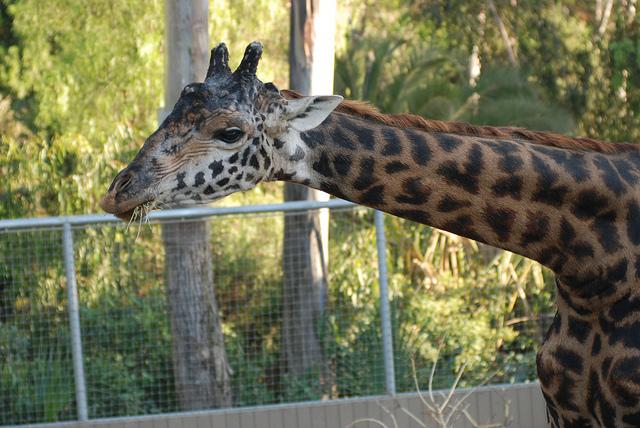Is it daytime?
Be succinct. Yes. Is the giraffe resting its head on the fence?
Write a very short answer. No. Is there a tree by the giraffe?
Answer briefly. Yes. 